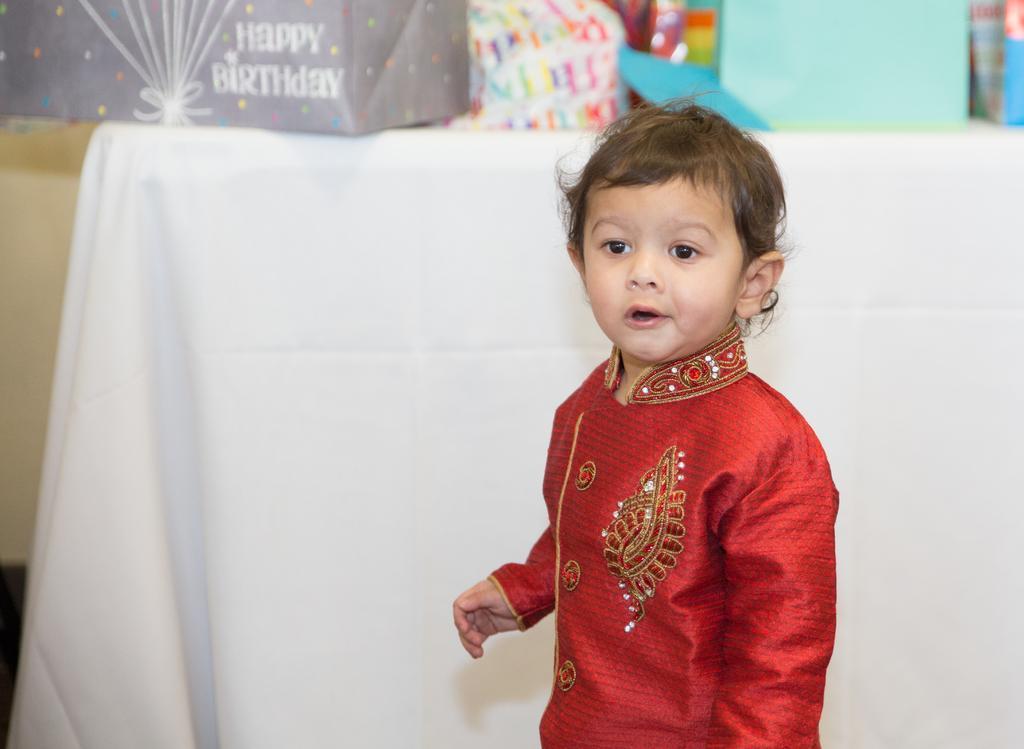In one or two sentences, can you explain what this image depicts? This image consists of a boy in red dress. In the background, there is a table covered with white cloth, on which there are gifts kept. 